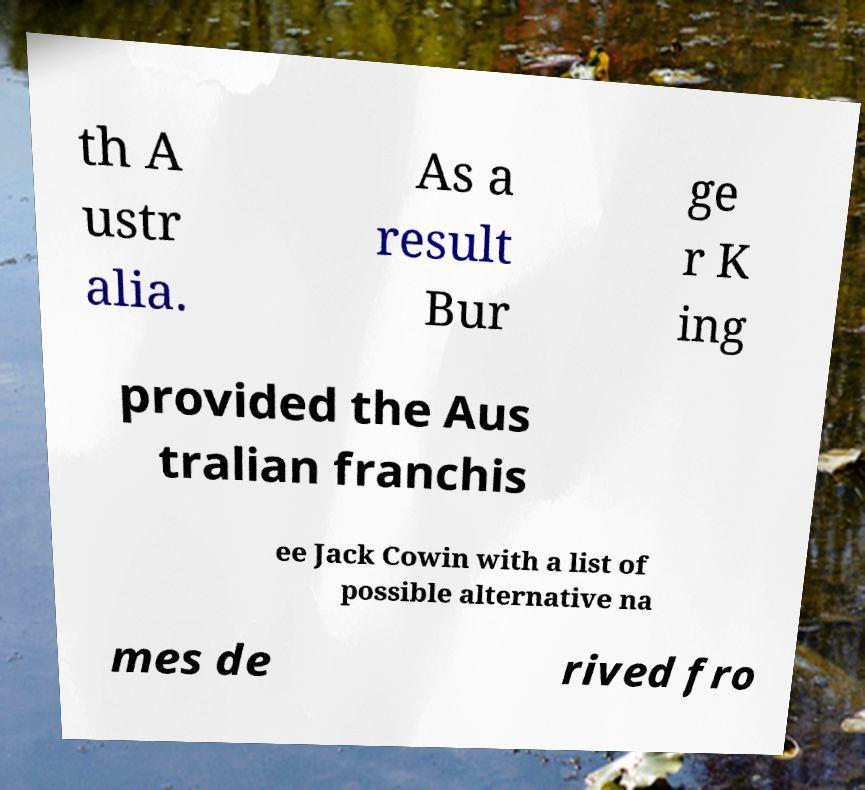I need the written content from this picture converted into text. Can you do that? th A ustr alia. As a result Bur ge r K ing provided the Aus tralian franchis ee Jack Cowin with a list of possible alternative na mes de rived fro 